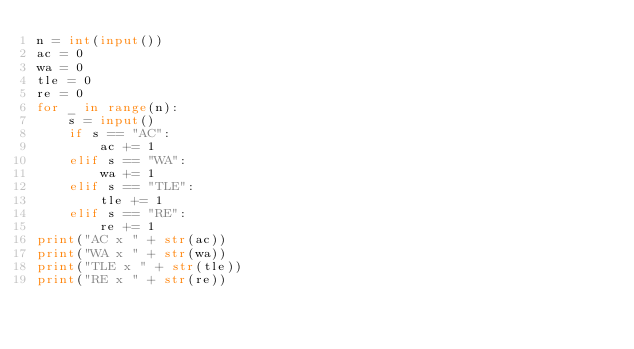Convert code to text. <code><loc_0><loc_0><loc_500><loc_500><_Python_>n = int(input())
ac = 0
wa = 0
tle = 0
re = 0
for _ in range(n):
    s = input()
    if s == "AC":
        ac += 1
    elif s == "WA":
        wa += 1
    elif s == "TLE":
        tle += 1
    elif s == "RE":
        re += 1
print("AC x " + str(ac))
print("WA x " + str(wa))
print("TLE x " + str(tle))
print("RE x " + str(re))
</code> 